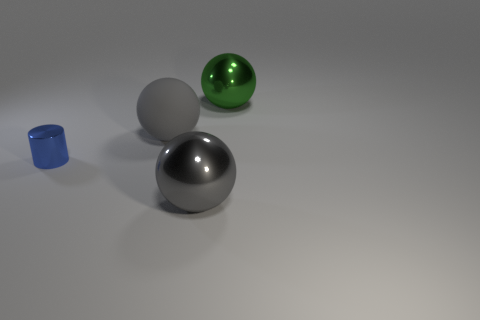What is the material of the big thing that is the same color as the big matte sphere?
Your answer should be compact. Metal. How many big balls have the same color as the matte object?
Provide a succinct answer. 1. What is the size of the gray rubber thing?
Make the answer very short. Large. There is a gray rubber object; is it the same shape as the big object that is in front of the blue shiny cylinder?
Keep it short and to the point. Yes. What color is the other large thing that is made of the same material as the green object?
Offer a terse response. Gray. There is a metallic ball in front of the large green sphere; what is its size?
Provide a succinct answer. Large. Is the number of blue metal cylinders that are left of the blue object less than the number of tiny things?
Keep it short and to the point. Yes. Is there anything else that is the same shape as the small shiny object?
Your answer should be very brief. No. Is the number of gray rubber spheres less than the number of big gray objects?
Keep it short and to the point. Yes. There is a big thing to the left of the gray object in front of the matte thing; what is its color?
Provide a succinct answer. Gray. 